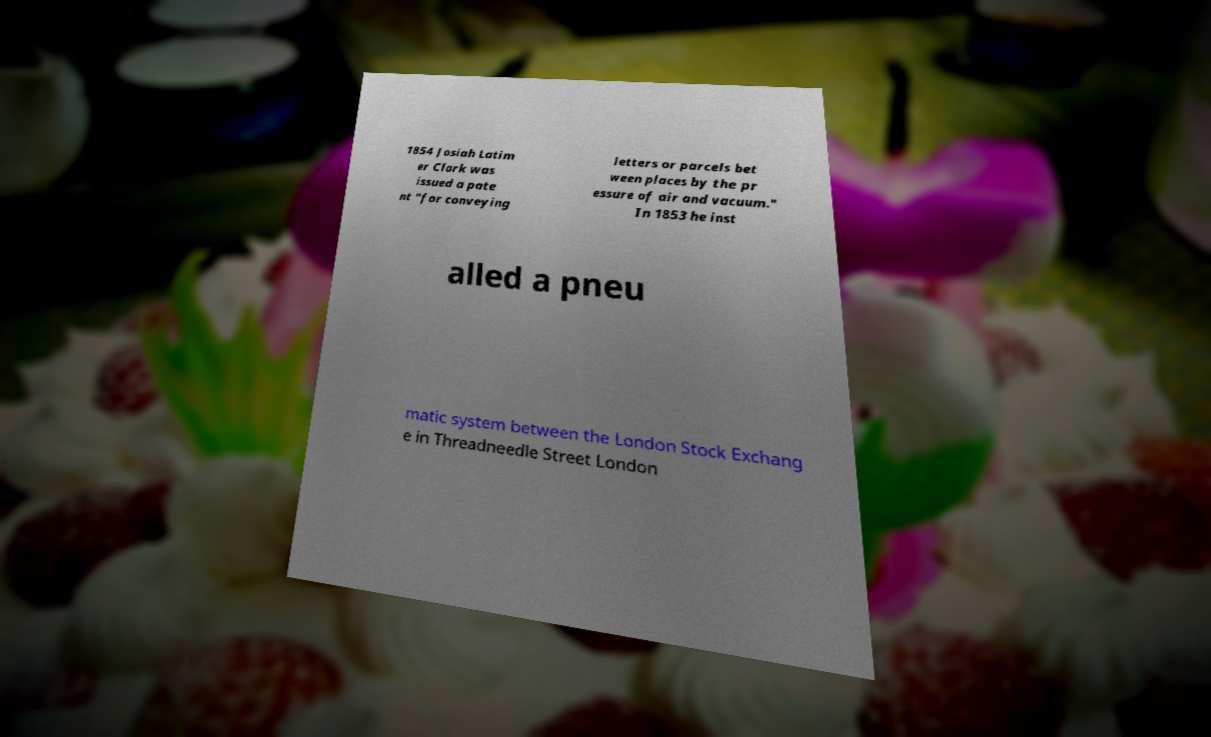Please read and relay the text visible in this image. What does it say? 1854 Josiah Latim er Clark was issued a pate nt "for conveying letters or parcels bet ween places by the pr essure of air and vacuum." In 1853 he inst alled a pneu matic system between the London Stock Exchang e in Threadneedle Street London 